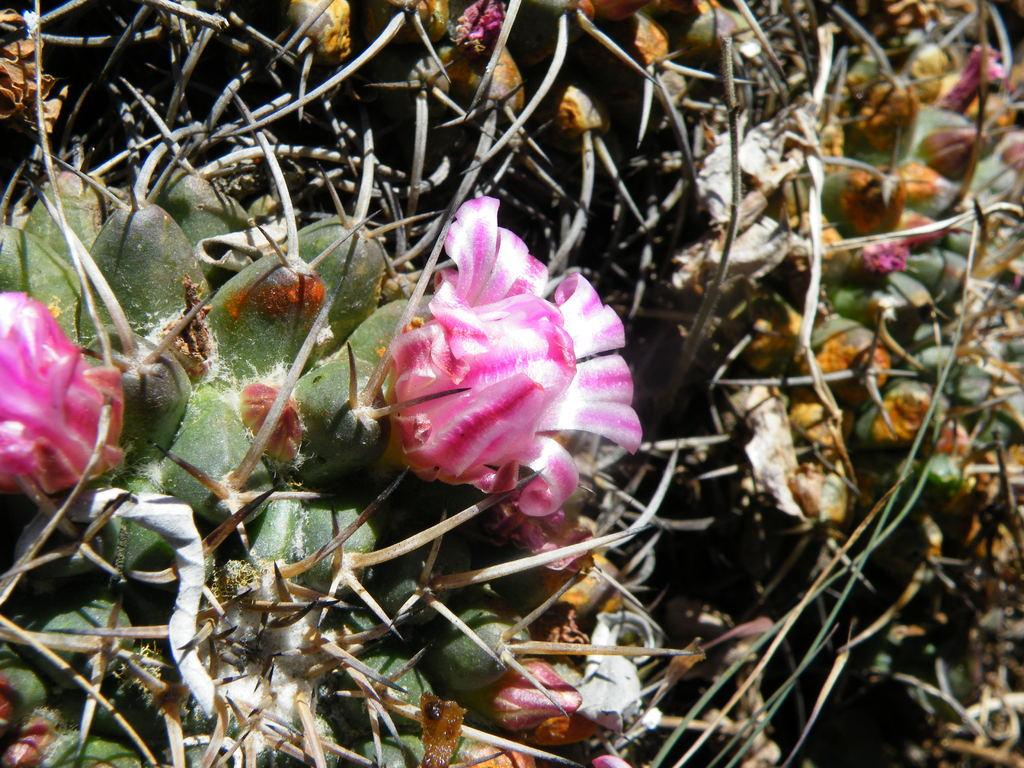What colors are the flowers in the image? The flowers in the image are pink and white. What color are the plants in the image? The plants in the image are green. What type of answer can be seen in the image? There is no answer present in the image; it features flowers and plants. Is there any eggnog visible in the image? There is no eggnog present in the image. 